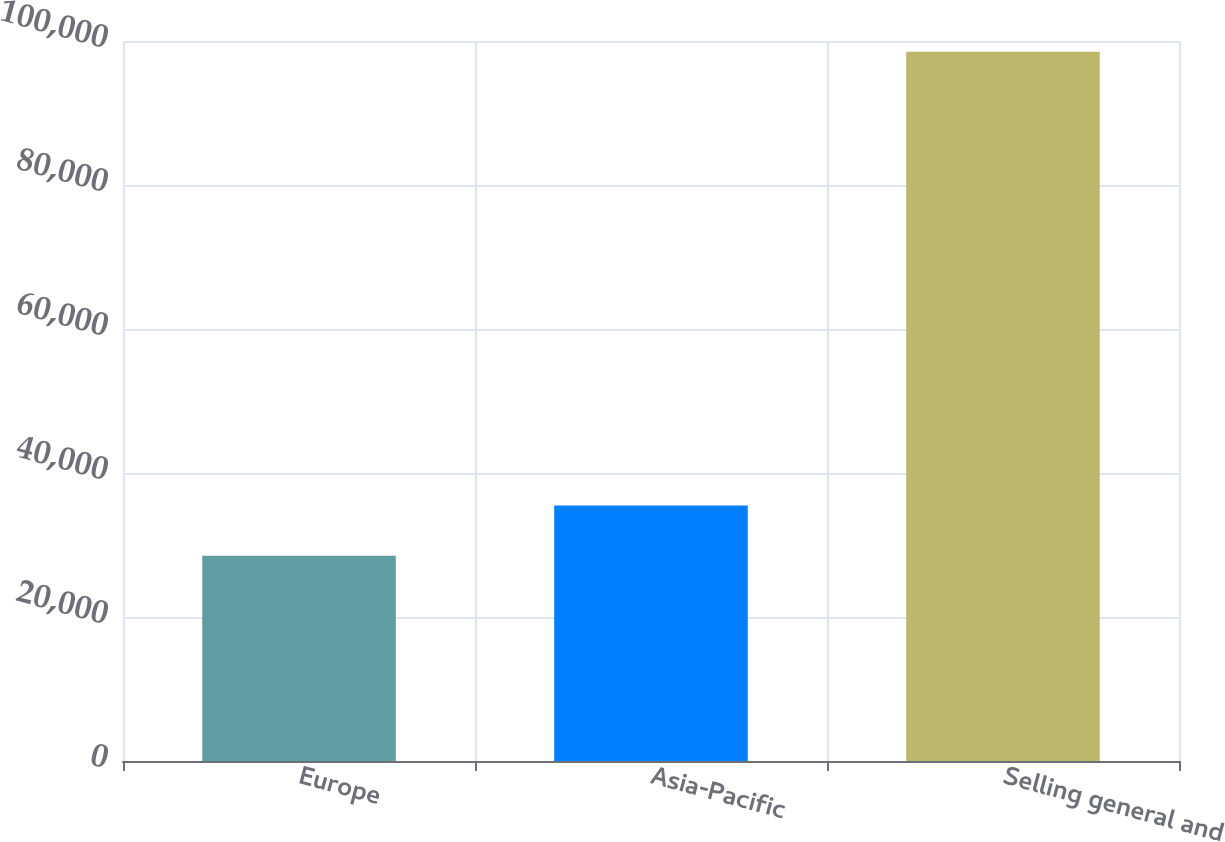Convert chart. <chart><loc_0><loc_0><loc_500><loc_500><bar_chart><fcel>Europe<fcel>Asia-Pacific<fcel>Selling general and<nl><fcel>28503<fcel>35502.9<fcel>98502<nl></chart> 